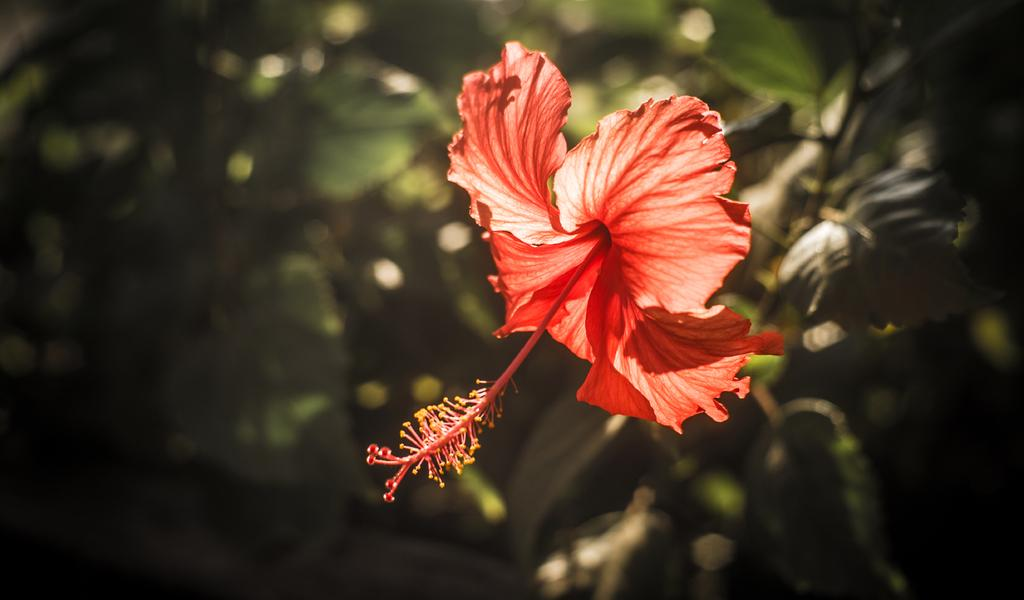What is present in the image? There is a plant in the image. What specific feature can be observed on the plant? The plant has a flower on it. What else can be seen in the background of the image? There are leaves visible in the background of the image. What is the weight of the secretary in the image? There is no secretary present in the image, so it is not possible to determine their weight. 